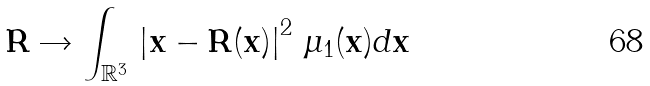Convert formula to latex. <formula><loc_0><loc_0><loc_500><loc_500>\mathbf R \rightarrow \int _ { \mathbb { R } ^ { 3 } } \, \left | \mathbf x - \mathbf R ( \mathbf x ) \right | ^ { 2 } \, \mu _ { 1 } ( \mathbf x ) d \mathbf x</formula> 